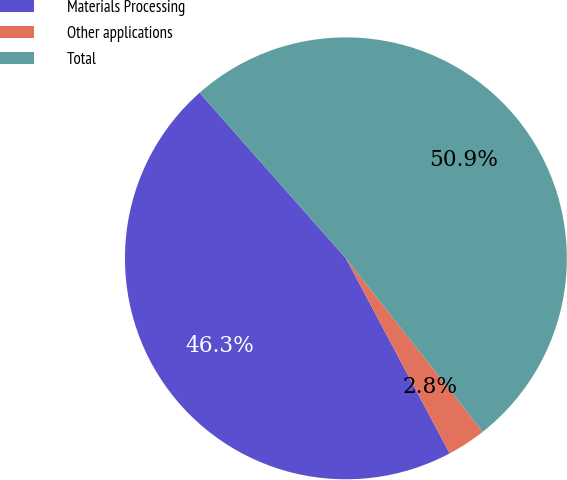<chart> <loc_0><loc_0><loc_500><loc_500><pie_chart><fcel>Materials Processing<fcel>Other applications<fcel>Total<nl><fcel>46.26%<fcel>2.85%<fcel>50.89%<nl></chart> 